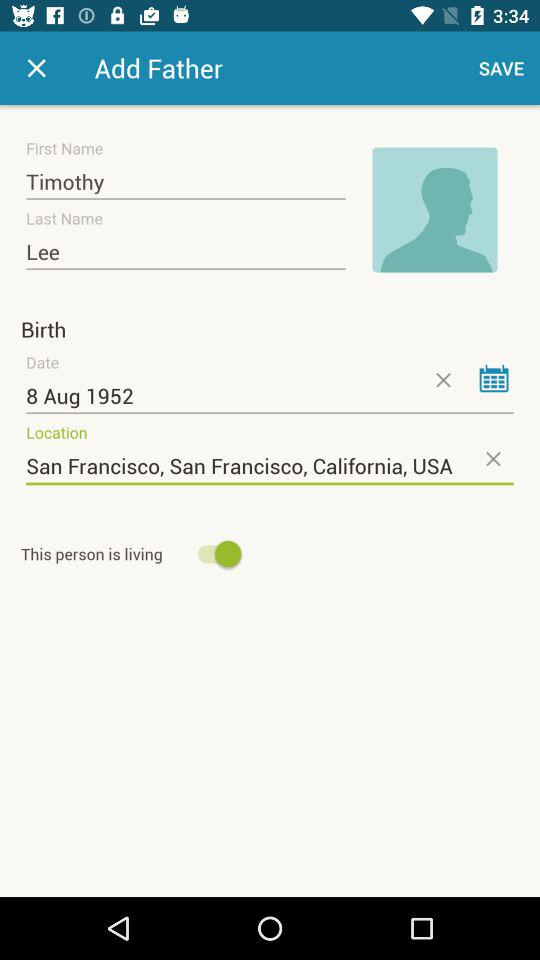What is the date of birth of the user? The date of birth is August 8, 1952. 